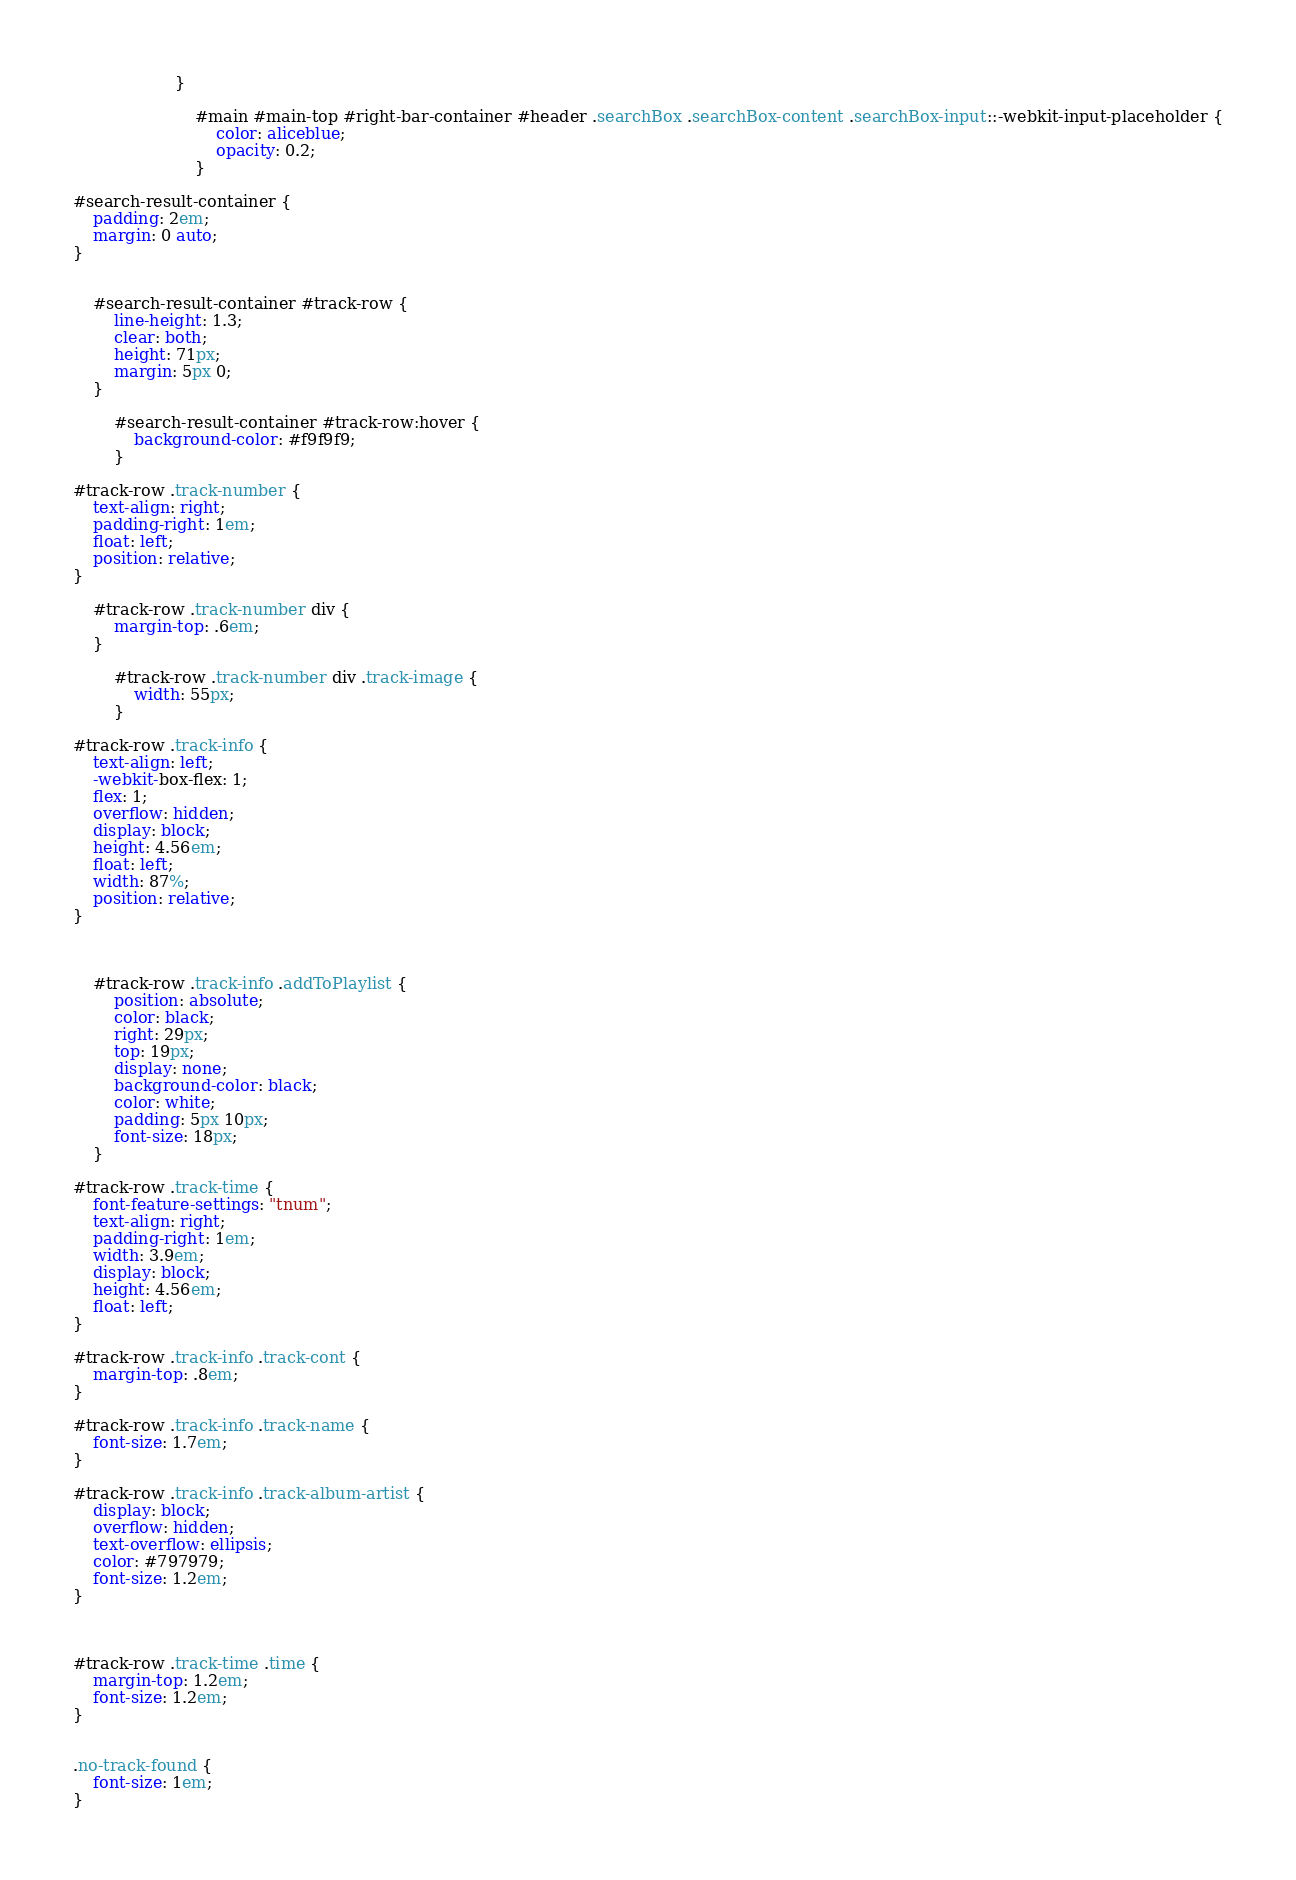<code> <loc_0><loc_0><loc_500><loc_500><_CSS_>                    }

                        #main #main-top #right-bar-container #header .searchBox .searchBox-content .searchBox-input::-webkit-input-placeholder {
                            color: aliceblue;
                            opacity: 0.2;
                        }

#search-result-container {
    padding: 2em;
    margin: 0 auto;
}


    #search-result-container #track-row {
        line-height: 1.3;
        clear: both;
        height: 71px;
        margin: 5px 0;
    }

        #search-result-container #track-row:hover {
            background-color: #f9f9f9;
        }

#track-row .track-number {
    text-align: right;
    padding-right: 1em;
    float: left;
    position: relative;
}

    #track-row .track-number div {
        margin-top: .6em;
    }

        #track-row .track-number div .track-image {
            width: 55px;
        }

#track-row .track-info {
    text-align: left;
    -webkit-box-flex: 1;
    flex: 1;
    overflow: hidden;
    display: block;
    height: 4.56em;
    float: left;
    width: 87%;
    position: relative;
}

   

    #track-row .track-info .addToPlaylist {
        position: absolute;
        color: black;
        right: 29px;
        top: 19px;
        display: none;
        background-color: black;
        color: white;
        padding: 5px 10px;
        font-size: 18px;
    }

#track-row .track-time {
    font-feature-settings: "tnum";
    text-align: right;
    padding-right: 1em;
    width: 3.9em;
    display: block;
    height: 4.56em;
    float: left;
}

#track-row .track-info .track-cont {
    margin-top: .8em;
}

#track-row .track-info .track-name {
    font-size: 1.7em;
}

#track-row .track-info .track-album-artist {
    display: block;
    overflow: hidden;
    text-overflow: ellipsis;
    color: #797979;
    font-size: 1.2em;
}



#track-row .track-time .time {
    margin-top: 1.2em;
    font-size: 1.2em;
}


.no-track-found {
    font-size: 1em;
}</code> 